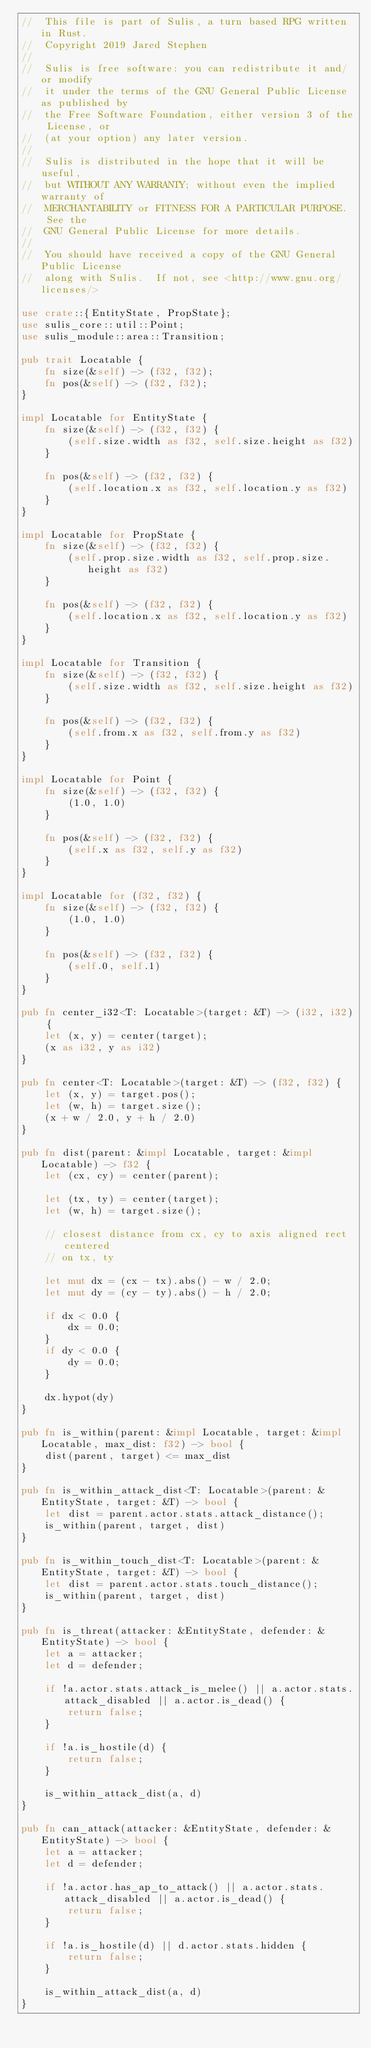<code> <loc_0><loc_0><loc_500><loc_500><_Rust_>//  This file is part of Sulis, a turn based RPG written in Rust.
//  Copyright 2019 Jared Stephen
//
//  Sulis is free software: you can redistribute it and/or modify
//  it under the terms of the GNU General Public License as published by
//  the Free Software Foundation, either version 3 of the License, or
//  (at your option) any later version.
//
//  Sulis is distributed in the hope that it will be useful,
//  but WITHOUT ANY WARRANTY; without even the implied warranty of
//  MERCHANTABILITY or FITNESS FOR A PARTICULAR PURPOSE.  See the
//  GNU General Public License for more details.
//
//  You should have received a copy of the GNU General Public License
//  along with Sulis.  If not, see <http://www.gnu.org/licenses/>

use crate::{EntityState, PropState};
use sulis_core::util::Point;
use sulis_module::area::Transition;

pub trait Locatable {
    fn size(&self) -> (f32, f32);
    fn pos(&self) -> (f32, f32);
}

impl Locatable for EntityState {
    fn size(&self) -> (f32, f32) {
        (self.size.width as f32, self.size.height as f32)
    }

    fn pos(&self) -> (f32, f32) {
        (self.location.x as f32, self.location.y as f32)
    }
}

impl Locatable for PropState {
    fn size(&self) -> (f32, f32) {
        (self.prop.size.width as f32, self.prop.size.height as f32)
    }

    fn pos(&self) -> (f32, f32) {
        (self.location.x as f32, self.location.y as f32)
    }
}

impl Locatable for Transition {
    fn size(&self) -> (f32, f32) {
        (self.size.width as f32, self.size.height as f32)
    }

    fn pos(&self) -> (f32, f32) {
        (self.from.x as f32, self.from.y as f32)
    }
}

impl Locatable for Point {
    fn size(&self) -> (f32, f32) {
        (1.0, 1.0)
    }

    fn pos(&self) -> (f32, f32) {
        (self.x as f32, self.y as f32)
    }
}

impl Locatable for (f32, f32) {
    fn size(&self) -> (f32, f32) {
        (1.0, 1.0)
    }

    fn pos(&self) -> (f32, f32) {
        (self.0, self.1)
    }
}

pub fn center_i32<T: Locatable>(target: &T) -> (i32, i32) {
    let (x, y) = center(target);
    (x as i32, y as i32)
}

pub fn center<T: Locatable>(target: &T) -> (f32, f32) {
    let (x, y) = target.pos();
    let (w, h) = target.size();
    (x + w / 2.0, y + h / 2.0)
}

pub fn dist(parent: &impl Locatable, target: &impl Locatable) -> f32 {
    let (cx, cy) = center(parent);

    let (tx, ty) = center(target);
    let (w, h) = target.size();

    // closest distance from cx, cy to axis aligned rect centered
    // on tx, ty

    let mut dx = (cx - tx).abs() - w / 2.0;
    let mut dy = (cy - ty).abs() - h / 2.0;

    if dx < 0.0 {
        dx = 0.0;
    }
    if dy < 0.0 {
        dy = 0.0;
    }

    dx.hypot(dy)
}

pub fn is_within(parent: &impl Locatable, target: &impl Locatable, max_dist: f32) -> bool {
    dist(parent, target) <= max_dist
}

pub fn is_within_attack_dist<T: Locatable>(parent: &EntityState, target: &T) -> bool {
    let dist = parent.actor.stats.attack_distance();
    is_within(parent, target, dist)
}

pub fn is_within_touch_dist<T: Locatable>(parent: &EntityState, target: &T) -> bool {
    let dist = parent.actor.stats.touch_distance();
    is_within(parent, target, dist)
}

pub fn is_threat(attacker: &EntityState, defender: &EntityState) -> bool {
    let a = attacker;
    let d = defender;

    if !a.actor.stats.attack_is_melee() || a.actor.stats.attack_disabled || a.actor.is_dead() {
        return false;
    }

    if !a.is_hostile(d) {
        return false;
    }

    is_within_attack_dist(a, d)
}

pub fn can_attack(attacker: &EntityState, defender: &EntityState) -> bool {
    let a = attacker;
    let d = defender;

    if !a.actor.has_ap_to_attack() || a.actor.stats.attack_disabled || a.actor.is_dead() {
        return false;
    }

    if !a.is_hostile(d) || d.actor.stats.hidden {
        return false;
    }

    is_within_attack_dist(a, d)
}
</code> 